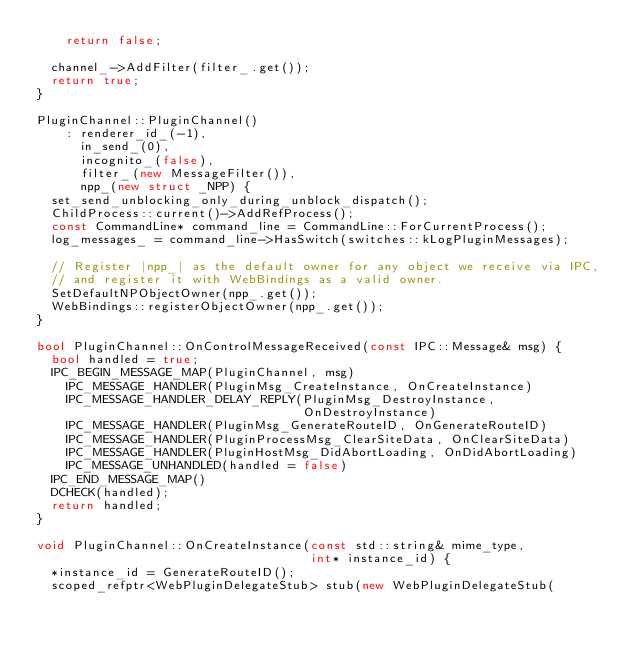<code> <loc_0><loc_0><loc_500><loc_500><_C++_>    return false;

  channel_->AddFilter(filter_.get());
  return true;
}

PluginChannel::PluginChannel()
    : renderer_id_(-1),
      in_send_(0),
      incognito_(false),
      filter_(new MessageFilter()),
      npp_(new struct _NPP) {
  set_send_unblocking_only_during_unblock_dispatch();
  ChildProcess::current()->AddRefProcess();
  const CommandLine* command_line = CommandLine::ForCurrentProcess();
  log_messages_ = command_line->HasSwitch(switches::kLogPluginMessages);

  // Register |npp_| as the default owner for any object we receive via IPC,
  // and register it with WebBindings as a valid owner.
  SetDefaultNPObjectOwner(npp_.get());
  WebBindings::registerObjectOwner(npp_.get());
}

bool PluginChannel::OnControlMessageReceived(const IPC::Message& msg) {
  bool handled = true;
  IPC_BEGIN_MESSAGE_MAP(PluginChannel, msg)
    IPC_MESSAGE_HANDLER(PluginMsg_CreateInstance, OnCreateInstance)
    IPC_MESSAGE_HANDLER_DELAY_REPLY(PluginMsg_DestroyInstance,
                                    OnDestroyInstance)
    IPC_MESSAGE_HANDLER(PluginMsg_GenerateRouteID, OnGenerateRouteID)
    IPC_MESSAGE_HANDLER(PluginProcessMsg_ClearSiteData, OnClearSiteData)
    IPC_MESSAGE_HANDLER(PluginHostMsg_DidAbortLoading, OnDidAbortLoading)
    IPC_MESSAGE_UNHANDLED(handled = false)
  IPC_END_MESSAGE_MAP()
  DCHECK(handled);
  return handled;
}

void PluginChannel::OnCreateInstance(const std::string& mime_type,
                                     int* instance_id) {
  *instance_id = GenerateRouteID();
  scoped_refptr<WebPluginDelegateStub> stub(new WebPluginDelegateStub(</code> 